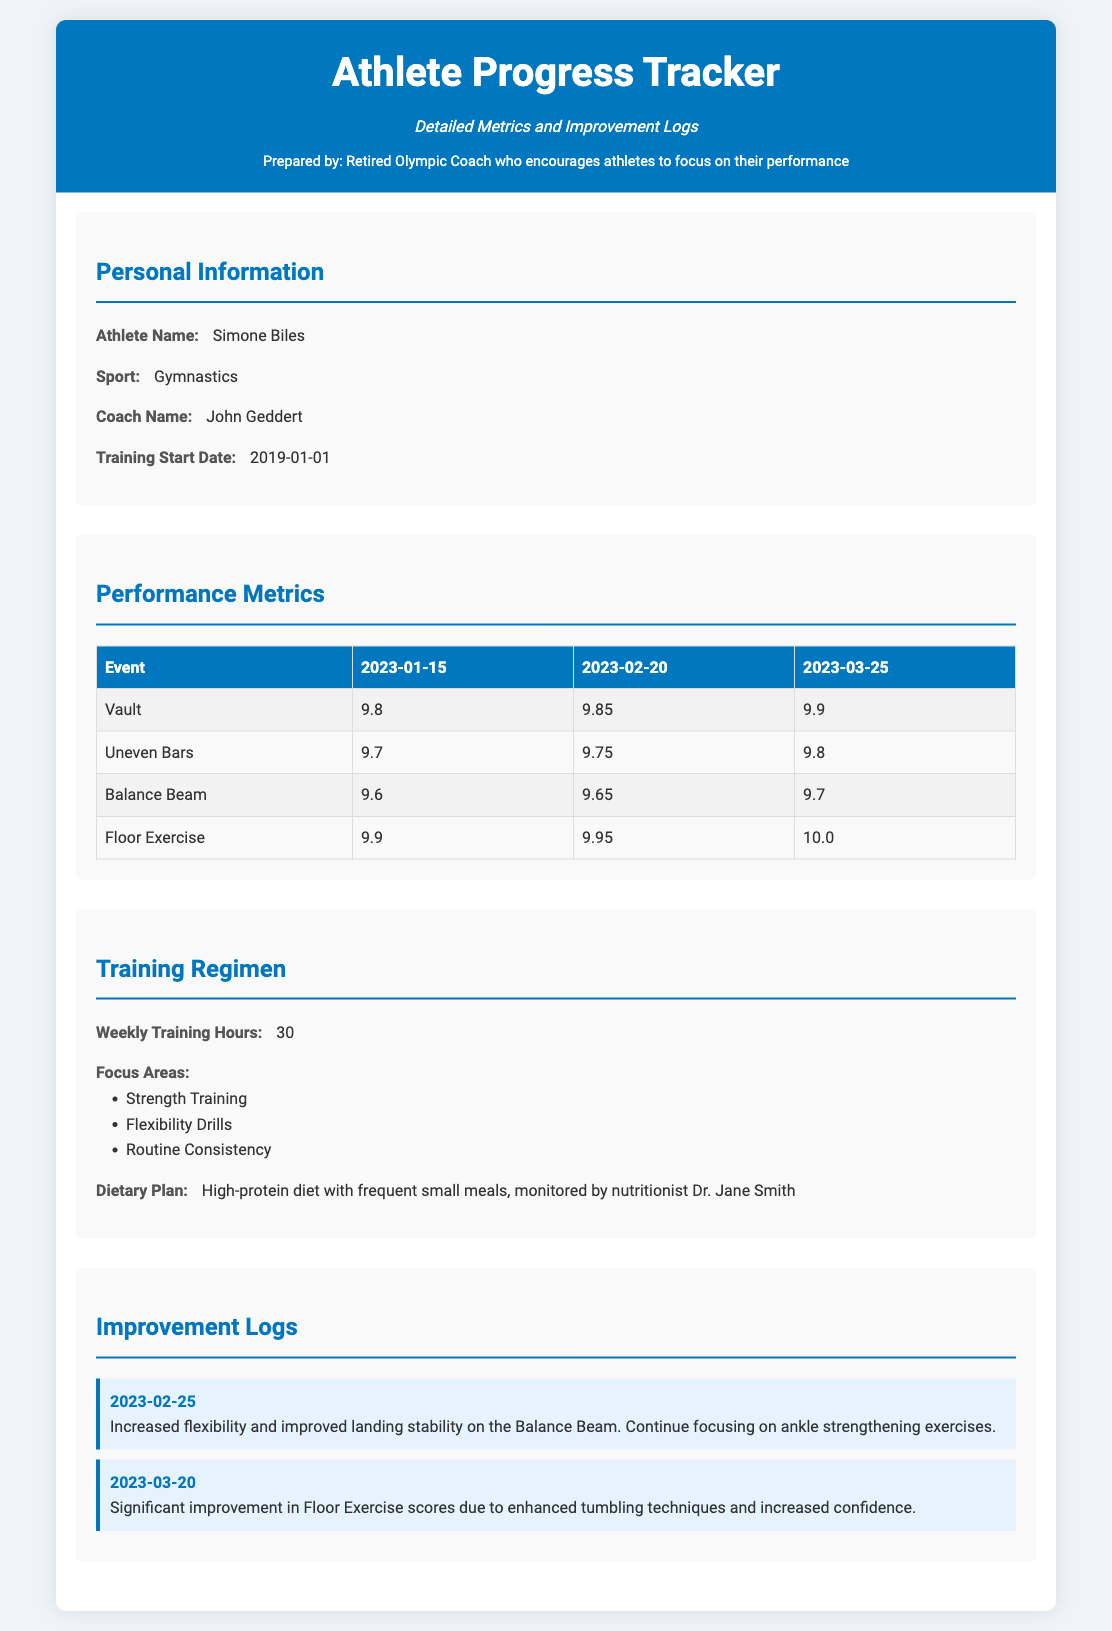What is the athlete's name? The athlete's name is presented in the personal information section of the document.
Answer: Simone Biles What sport does the athlete participate in? The sport of the athlete is listed under personal information.
Answer: Gymnastics Who is the coach of the athlete? The document specifies the name of the coach in the personal information section.
Answer: John Geddert On what date did the athlete's training start? The training start date is found in the personal information section.
Answer: 2019-01-01 What was the score for Vault on 2023-03-25? The score for Vault is indicated in the performance metrics table for the given date.
Answer: 9.9 What is the weekly training hours for the athlete? Weekly training hours are noted in the training regimen section.
Answer: 30 What dietary plan is the athlete following? The dietary plan is described in the training regimen section, mentioning specific dietary details.
Answer: High-protein diet with frequent small meals What was noted in the improvement log on 2023-02-25? The notes from the improvement log provide insights into progress made on that date.
Answer: Increased flexibility and improved landing stability on the Balance Beam Which performance area had significant improvement noted on 2023-03-20? The improvement log highlights which performance area improved significantly.
Answer: Floor Exercise 